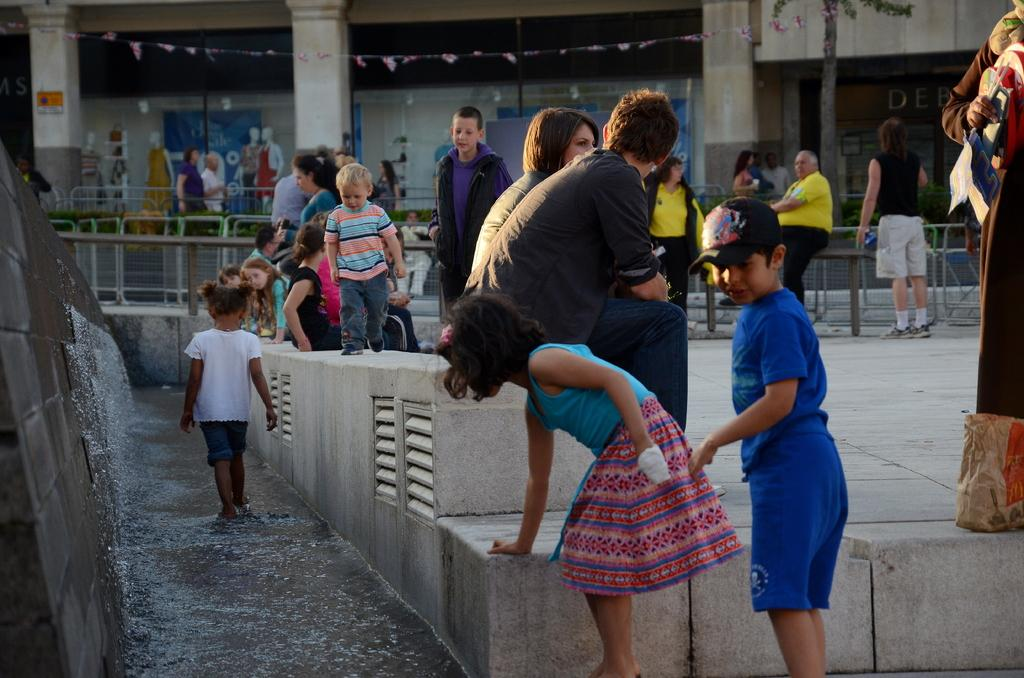Who or what can be seen in the image? There are people in the image. What is the purpose of the fence in the image? The fence in the image serves as a barrier or boundary. What type of furniture is present in the image? There are chairs in the image. What type of structure is visible in the image? There is a building in the image. What type of pin is holding the wall together in the image? There is no pin or wall present in the image; it only features people, a fence, chairs, and a building. 